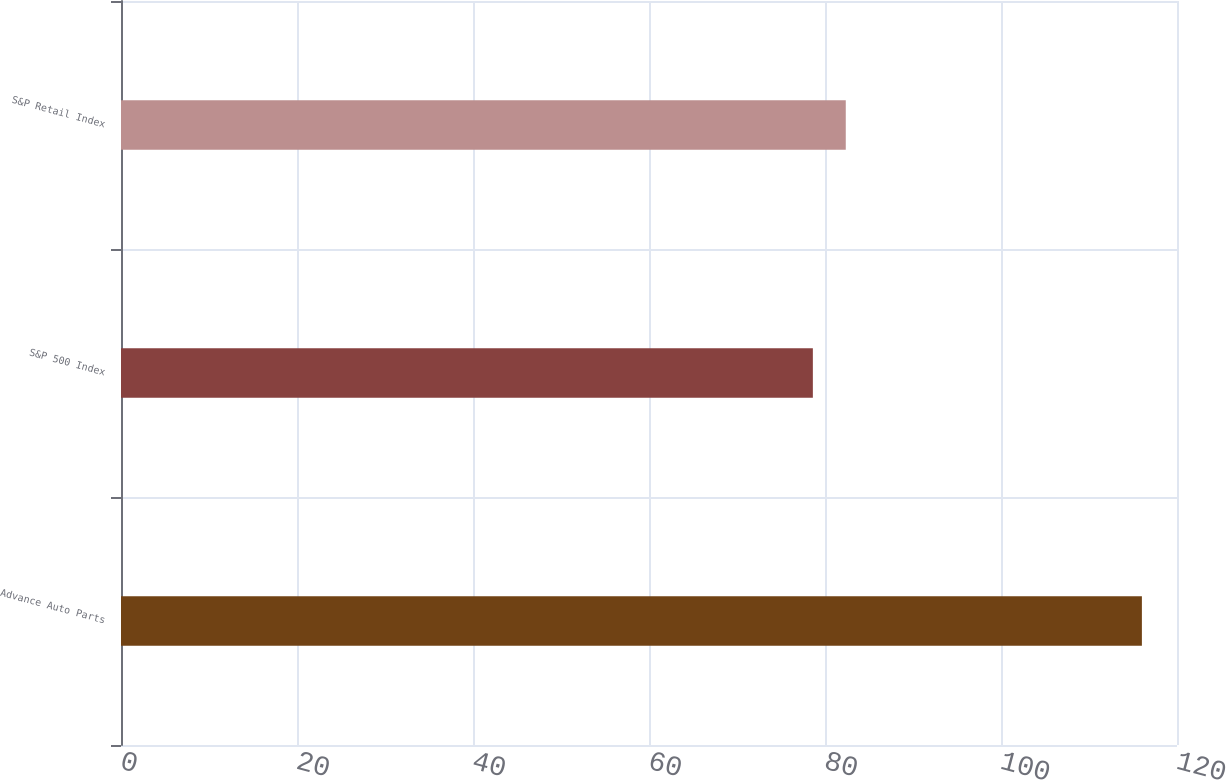<chart> <loc_0><loc_0><loc_500><loc_500><bar_chart><fcel>Advance Auto Parts<fcel>S&P 500 Index<fcel>S&P Retail Index<nl><fcel>116.01<fcel>78.62<fcel>82.36<nl></chart> 